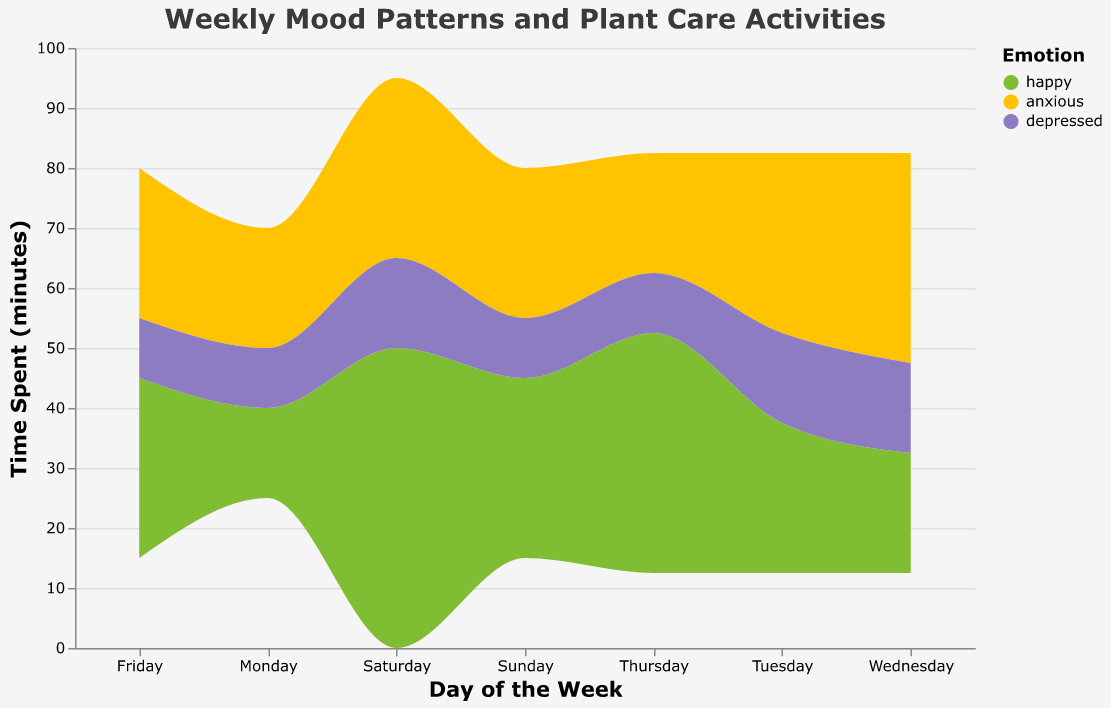What is the title of the figure? The title is located at the top of the figure and is often larger in text size compared to other labels. It provides a brief description of what the figure represents.
Answer: Weekly Mood Patterns and Plant Care Activities On which day was the most time spent on happy plant care activities? By looking at the colored regions corresponding to "happy" for each day, identify the day with the largest area in this color.
Answer: Saturday Which emotion had more plant care activities on Monday, anxious or happy? Compare the colored areas representing "anxious" and "happy" on Monday. The area associated with each emotion depicts the time spent.
Answer: Anxious What was the total time spent on plant care activities on Friday? Sum the "time spent (minutes)" for all plant care activities on Friday, considering all emotions.
Answer: 30 + 25 + 10 = 65 minutes Which emotion had the smallest total time spent on plant care activities throughout the week? Sum the time spent for each emotion across all days and compare the totals.
Answer: Depressed What plant care activity was performed the most frequently while feeling depressed? Find the "plant care activity" listed under the "depressed" emotion for each day and check which one appears most frequently.
Answer: Watered plants How does the pattern of happy plant care activities change from Monday to Sunday? Observe the changes in the height and width of the "happy" colored area from Monday to Sunday.
Answer: It generally increases from Monday to Saturday and slightly decreases on Sunday Which day had the most balanced distribution of emotions in plant care activities? Look for the day where the areas of the colored regions (happy, anxious, depressed) are closest to being equal in size.
Answer: Thursday What is the largest single chunk of time spent on any activity, and on which day did this occur? Identify the tallest peak in the figure, which represents the maximum time spent on a single activity. Check the corresponding day and activity.
Answer: 50 minutes on Saturday (planted herbs) 